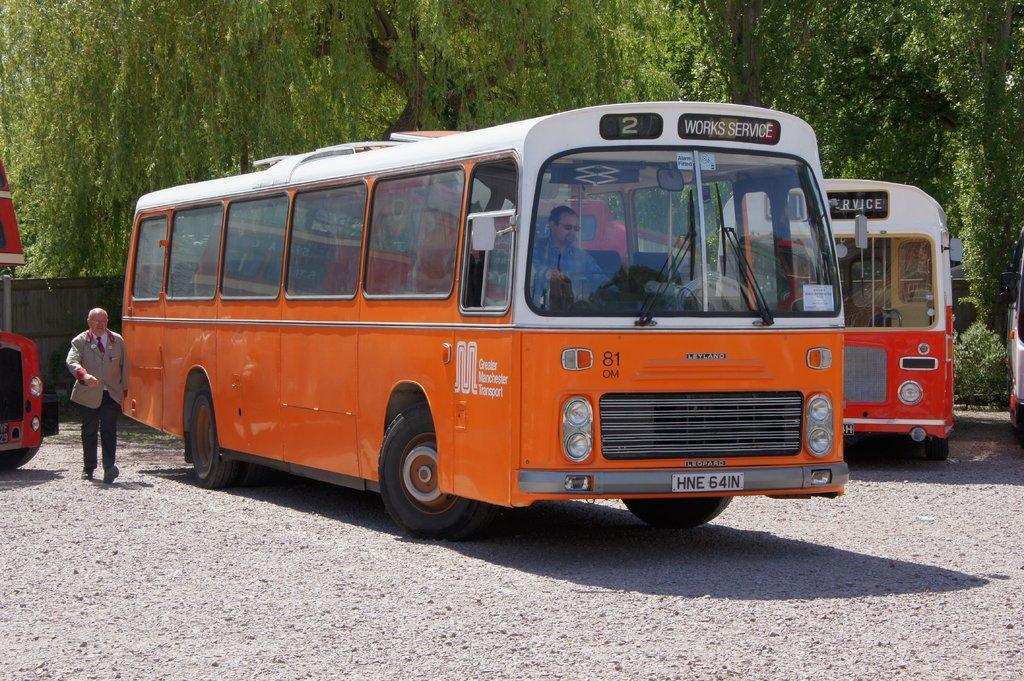<image>
Give a short and clear explanation of the subsequent image. An orange bus has a front display that says works service. 